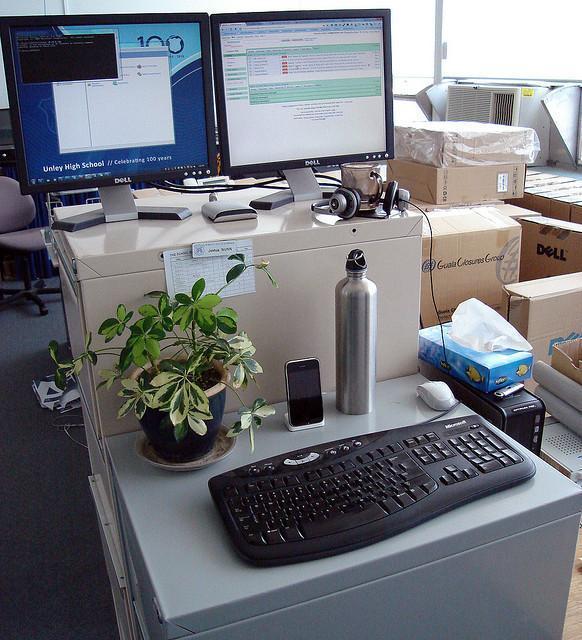How many tvs are in the picture?
Give a very brief answer. 2. 